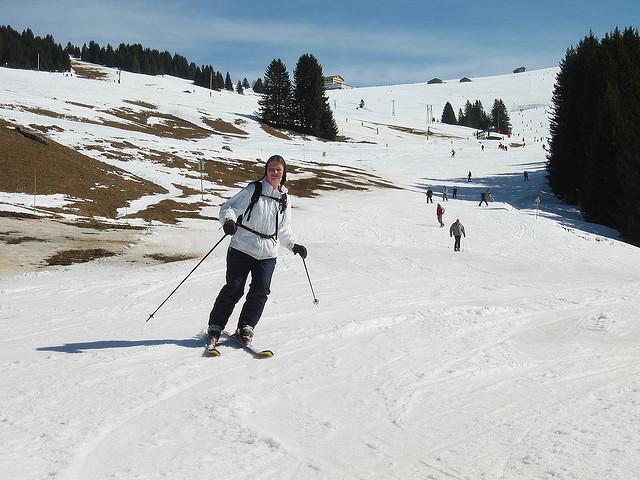What is the man holding?
Short answer required. Poles. Is it cold out?
Give a very brief answer. Yes. Where are the people?
Quick response, please. Ski slope. 